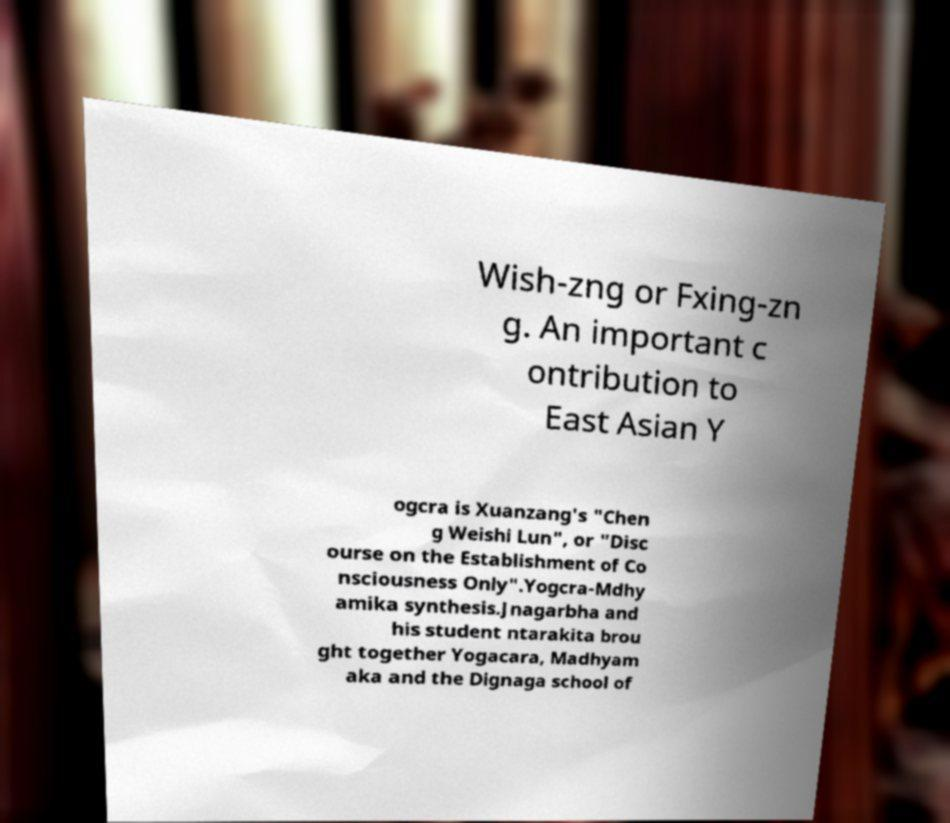Please identify and transcribe the text found in this image. Wish-zng or Fxing-zn g. An important c ontribution to East Asian Y ogcra is Xuanzang's "Chen g Weishi Lun", or "Disc ourse on the Establishment of Co nsciousness Only".Yogcra-Mdhy amika synthesis.Jnagarbha and his student ntarakita brou ght together Yogacara, Madhyam aka and the Dignaga school of 